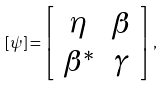Convert formula to latex. <formula><loc_0><loc_0><loc_500><loc_500>[ \psi ] = \left [ \begin{array} { c c } \eta & \beta \\ \beta ^ { * } & \gamma \end{array} \right ] ,</formula> 